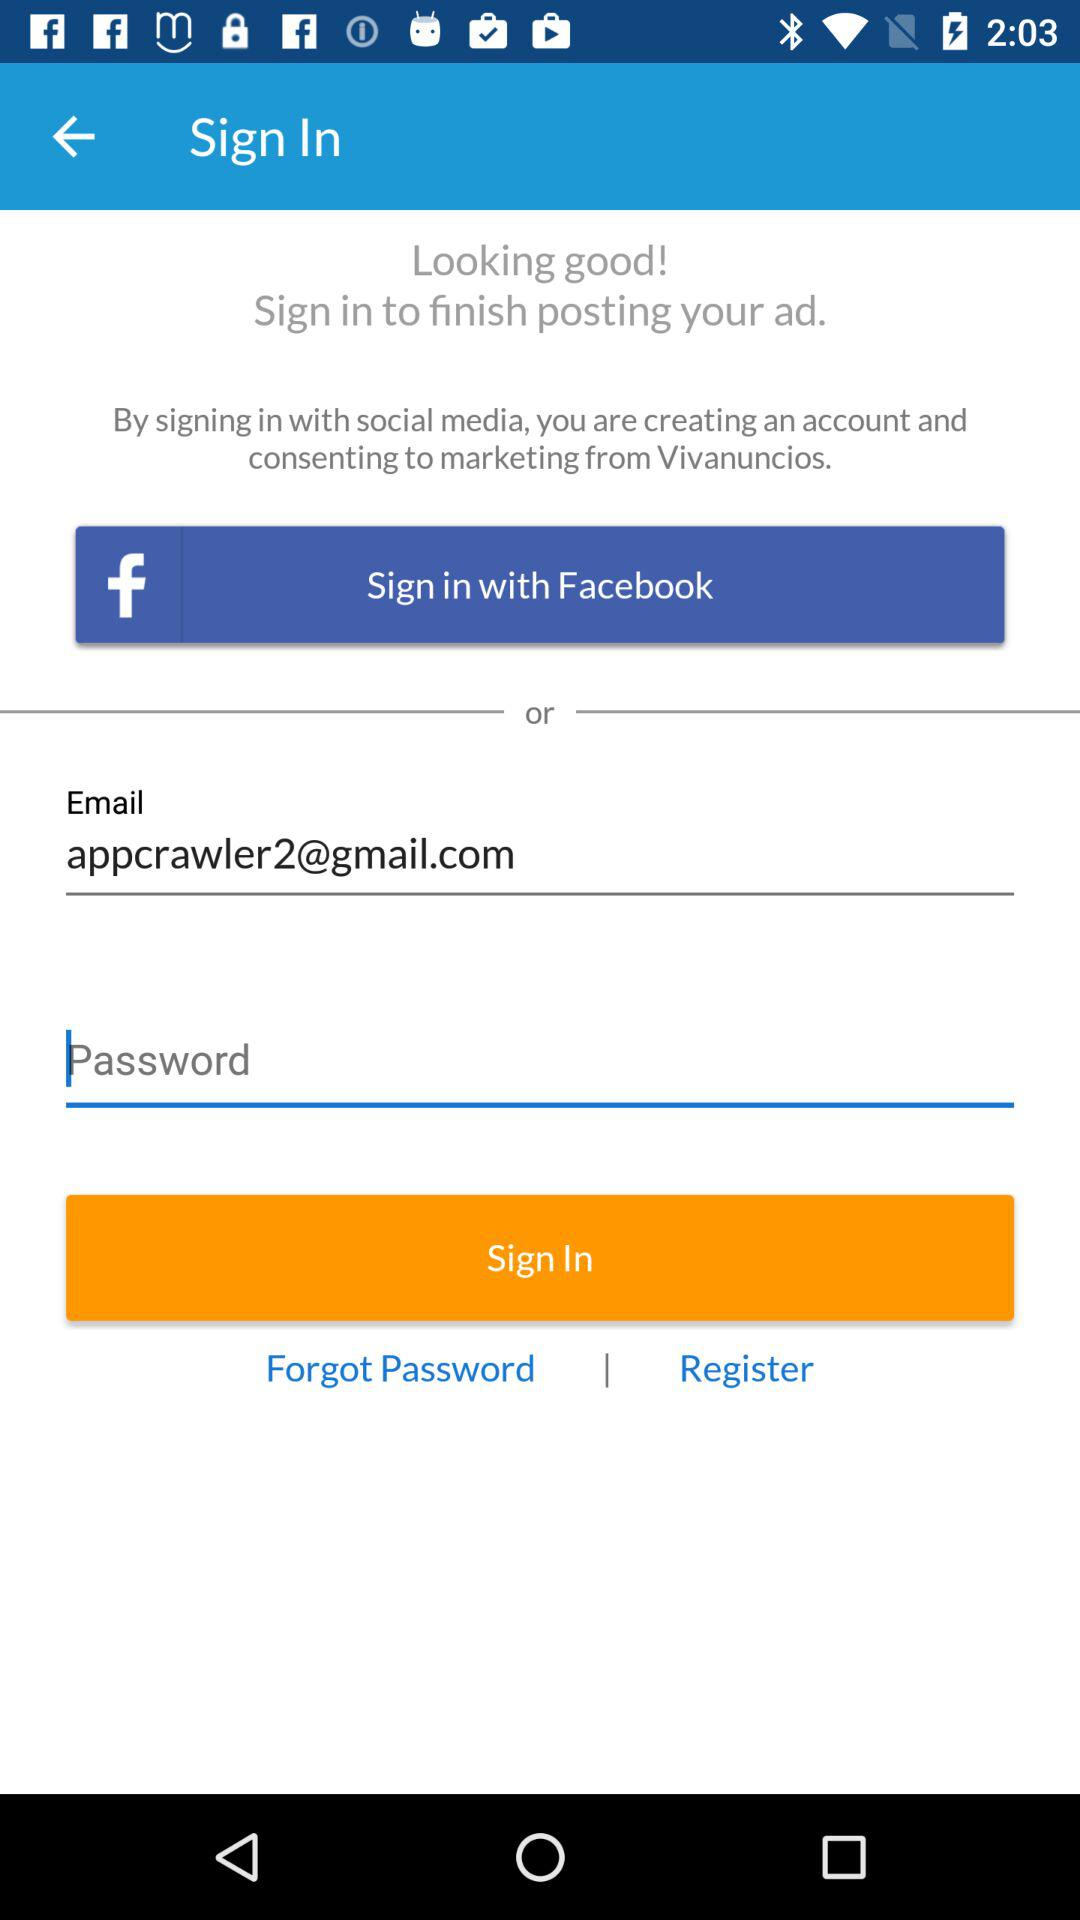What are the other options to log in? The other options are "Facebook" and "Email". 